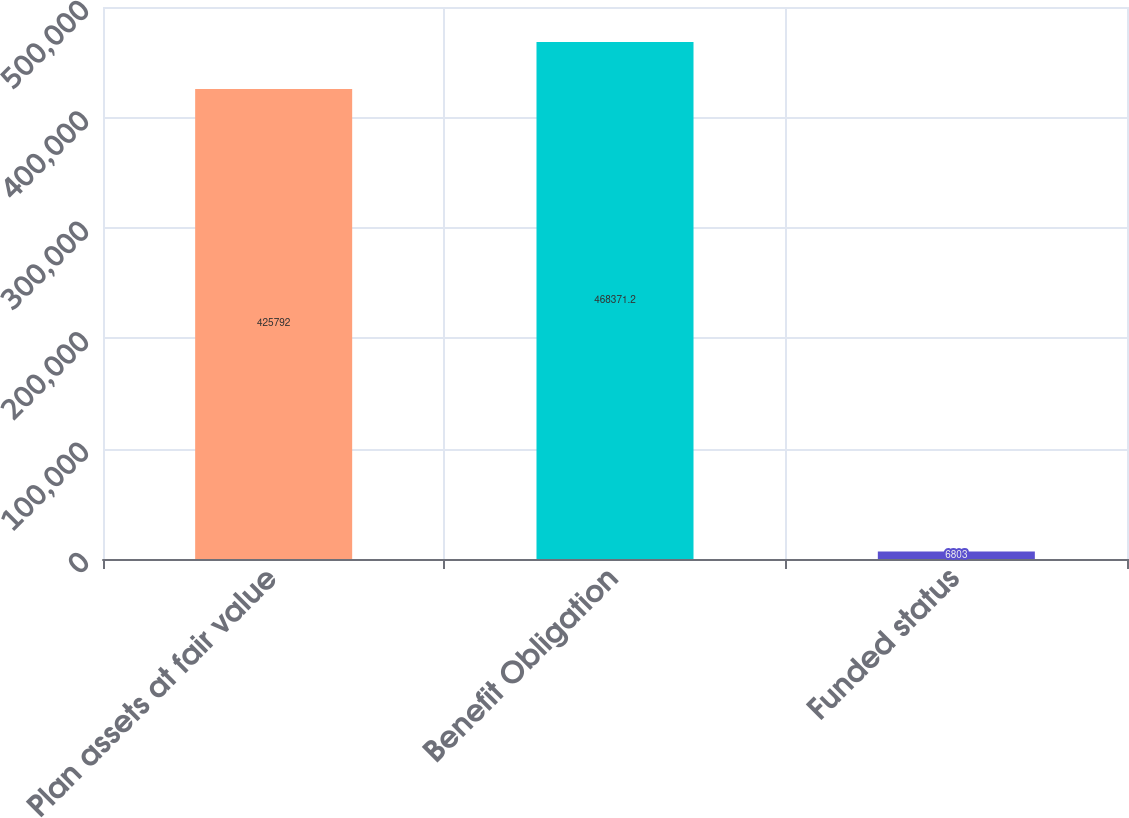Convert chart. <chart><loc_0><loc_0><loc_500><loc_500><bar_chart><fcel>Plan assets at fair value<fcel>Benefit Obligation<fcel>Funded status<nl><fcel>425792<fcel>468371<fcel>6803<nl></chart> 